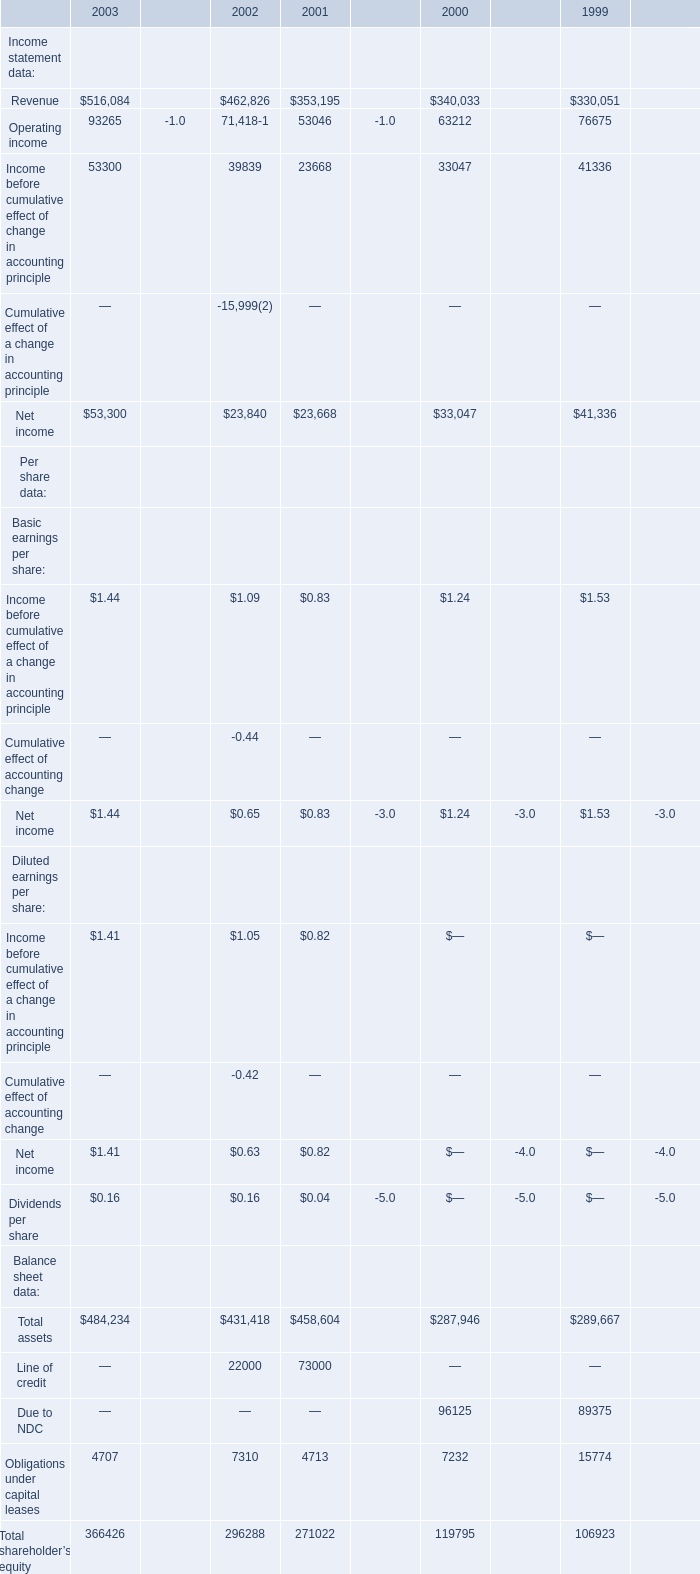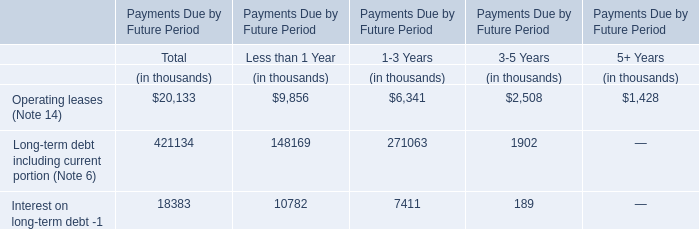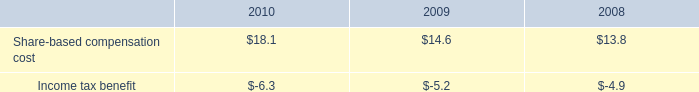What was the average of Net income of Basic earnings per share in 2003, 2002 and 2001 ? 
Computations: (((1.44 + 0.65) + 0.83) / 3)
Answer: 0.97333. 